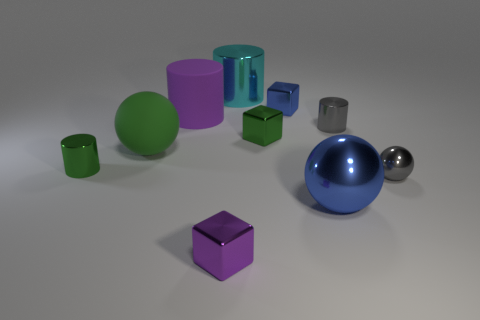Subtract all balls. How many objects are left? 7 Subtract 1 cyan cylinders. How many objects are left? 9 Subtract all small gray spheres. Subtract all small metallic spheres. How many objects are left? 8 Add 4 small blue objects. How many small blue objects are left? 5 Add 7 big yellow things. How many big yellow things exist? 7 